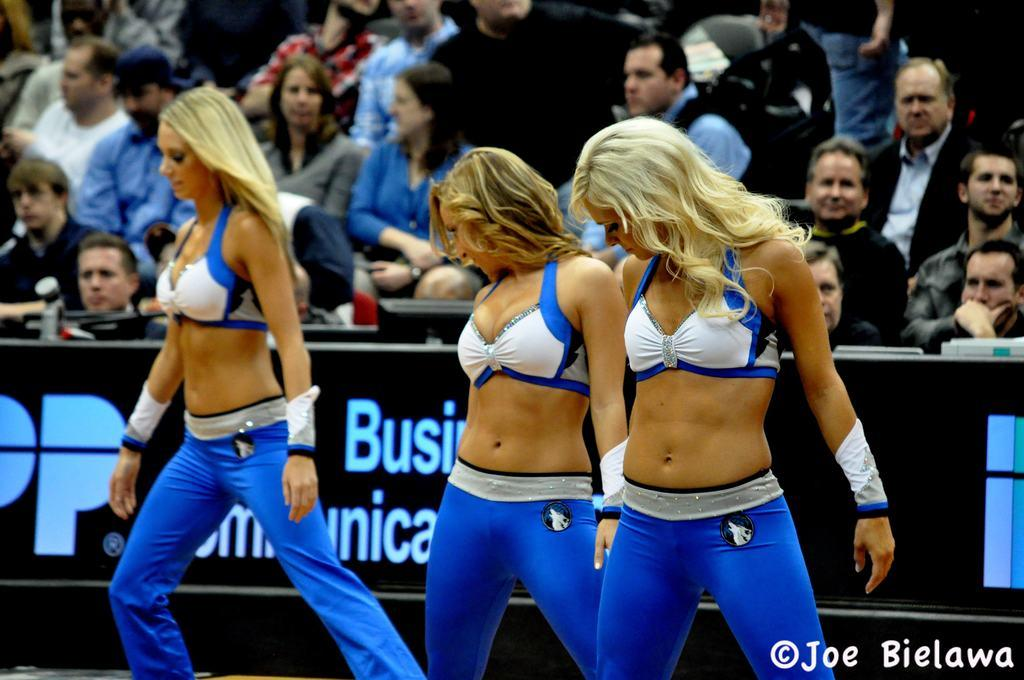<image>
Summarize the visual content of the image. some cheerleaders and the name joe in the corner 